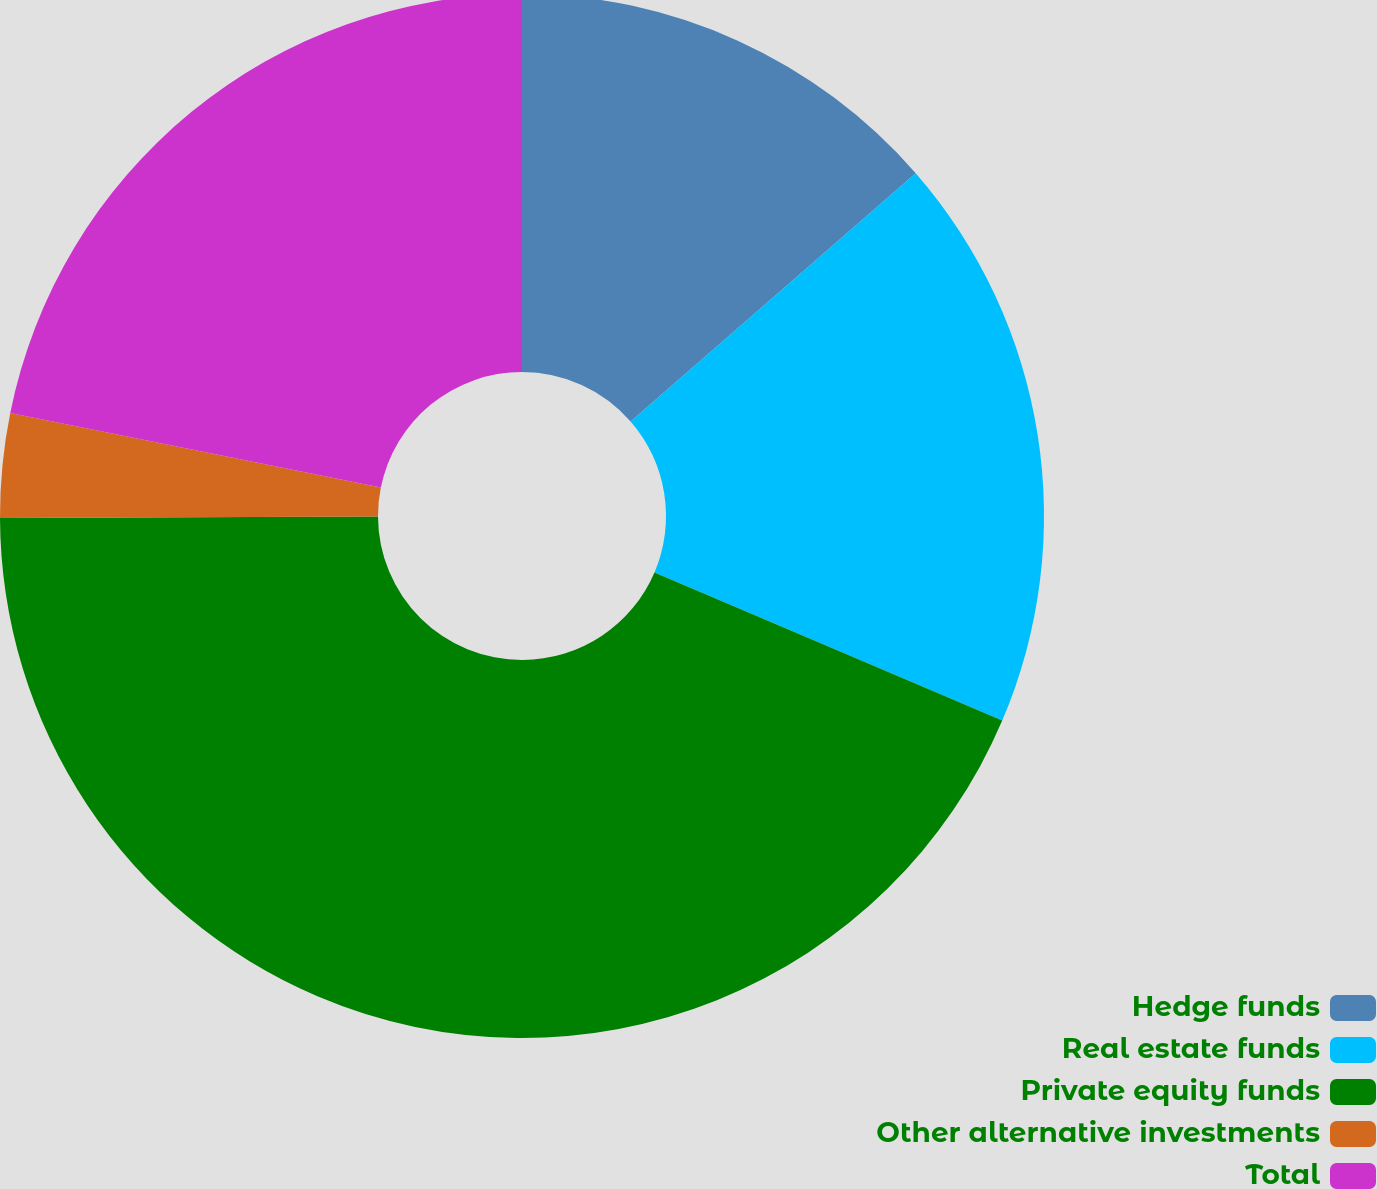<chart> <loc_0><loc_0><loc_500><loc_500><pie_chart><fcel>Hedge funds<fcel>Real estate funds<fcel>Private equity funds<fcel>Other alternative investments<fcel>Total<nl><fcel>13.6%<fcel>17.81%<fcel>43.53%<fcel>3.22%<fcel>21.84%<nl></chart> 